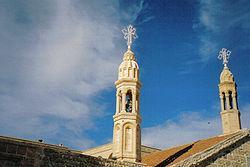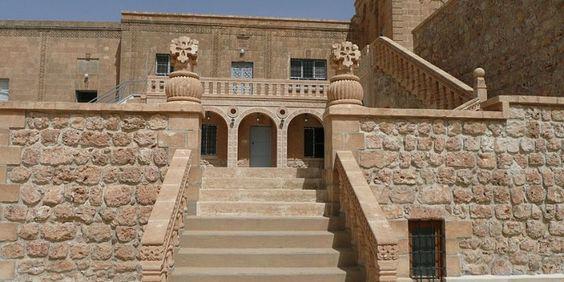The first image is the image on the left, the second image is the image on the right. For the images shown, is this caption "A set of stairs lead to an arch in at least one image." true? Answer yes or no. Yes. 